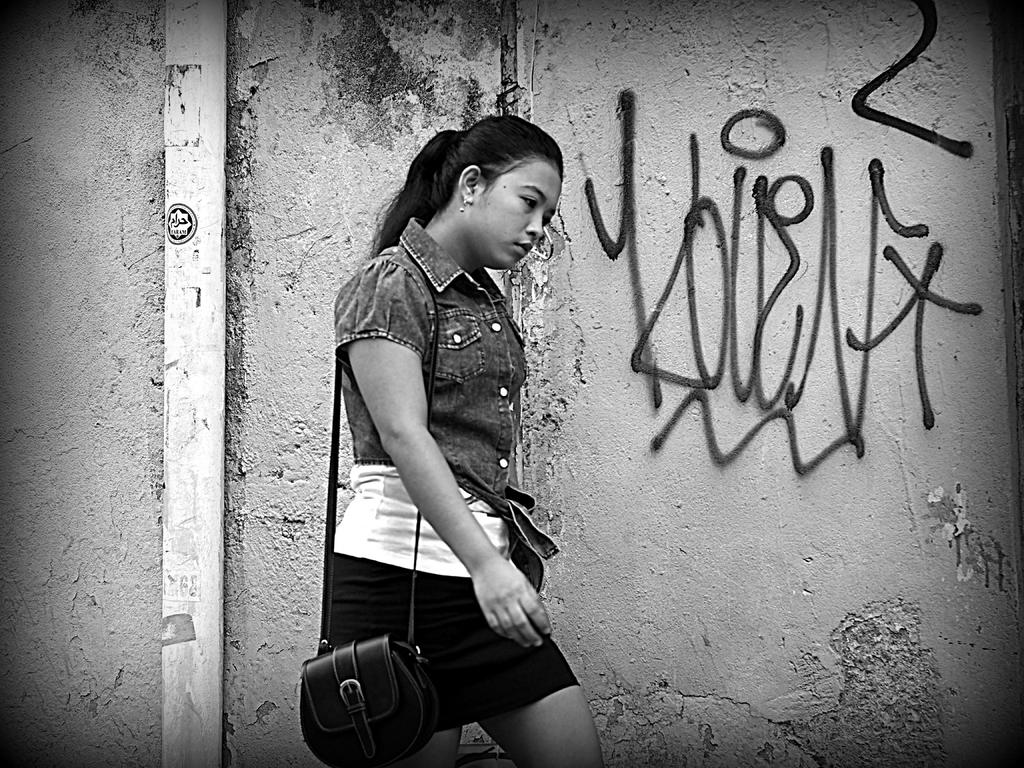What is the color scheme of the image? The image is black and white. Can you describe the person in the image? There is a person in the image, and they are carrying a bag. What is the person doing in the image? The person is standing in the image. What can be seen in the background of the image? There is a wall in the background of the image, and it has some text on it. Additionally, there is an object in the background. What type of jeans is the person wearing in the image? The image is black and white, so it is not possible to determine the type of jeans the person might be wearing. Additionally, the provided facts do not mention any clothing items. 